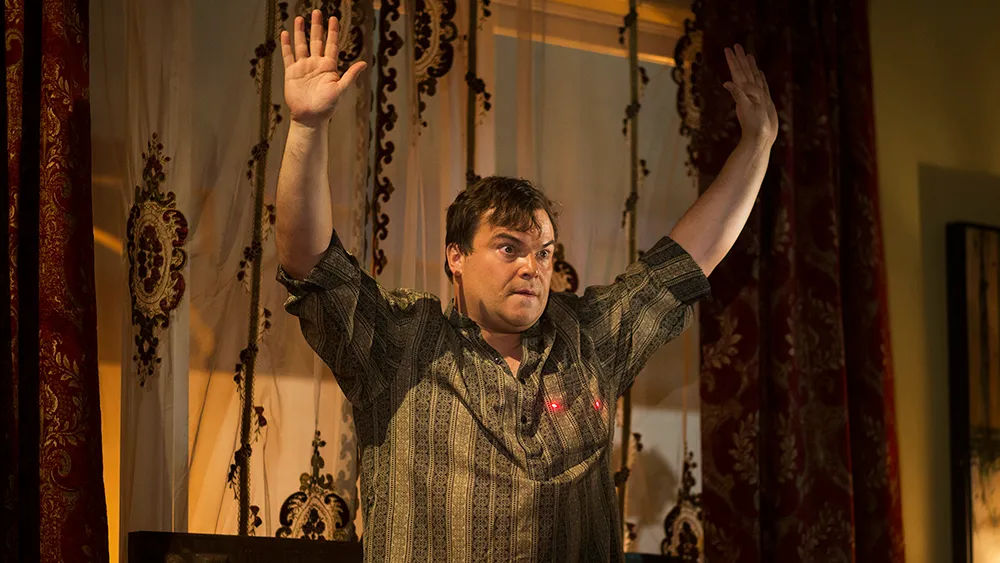What do you see happening in this image? In the image, a man appears on stage, raising his hands up in a gesture that could suggest surprise or interaction with an audience. He wears a casual, patterned shirt and stands against a backdrop adorned with lavish curtains and a chandelier, suggesting a theatrical or dramatic setting. His facial expression and the dynamic pose add a vibrant energy to the scene, indicating a moment of significant expression or announcement. 